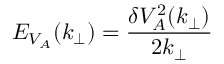<formula> <loc_0><loc_0><loc_500><loc_500>E _ { V _ { A } } ( k _ { \perp } ) = \frac { \delta V _ { A } ^ { 2 } ( k _ { \perp } ) } { 2 k _ { \perp } }</formula> 